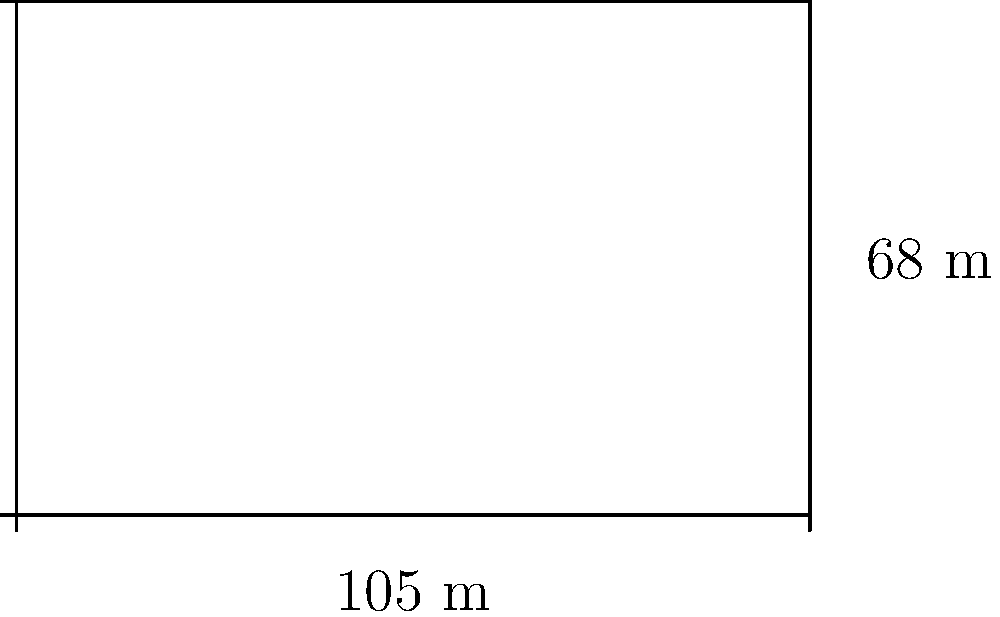Given a soccer field with dimensions 105 meters in length and 68 meters in width, calculate the total area of the field in square meters. How would this data impact player positioning and team strategy? To calculate the area of the soccer field, we need to use the formula for the area of a rectangle:

$$A = l \times w$$

Where:
$A$ = Area
$l$ = Length
$w$ = Width

Given:
Length ($l$) = 105 meters
Width ($w$) = 68 meters

Step 1: Substitute the values into the formula
$$A = 105 \times 68$$

Step 2: Multiply
$$A = 7,140 \text{ square meters}$$

Impact on player positioning and team strategy:
1. Space utilization: Knowing the exact area allows for precise calculations of player density and optimal positioning.
2. Running distances: The total area can be used to estimate the average distance covered by players during a match.
3. Tactical analysis: Different zones of the field can be analyzed based on their relative sizes to the total area.
4. Training regimens: Conditioning programs can be tailored based on the specific dimensions and area of the field.
5. Performance metrics: Player movement and positioning data can be normalized against the field size for more accurate comparisons.

This data-driven approach enables coaches to make informed decisions about formation, pressing intensity, and overall game strategy based on quantifiable spatial relationships rather than intuition.
Answer: 7,140 square meters 